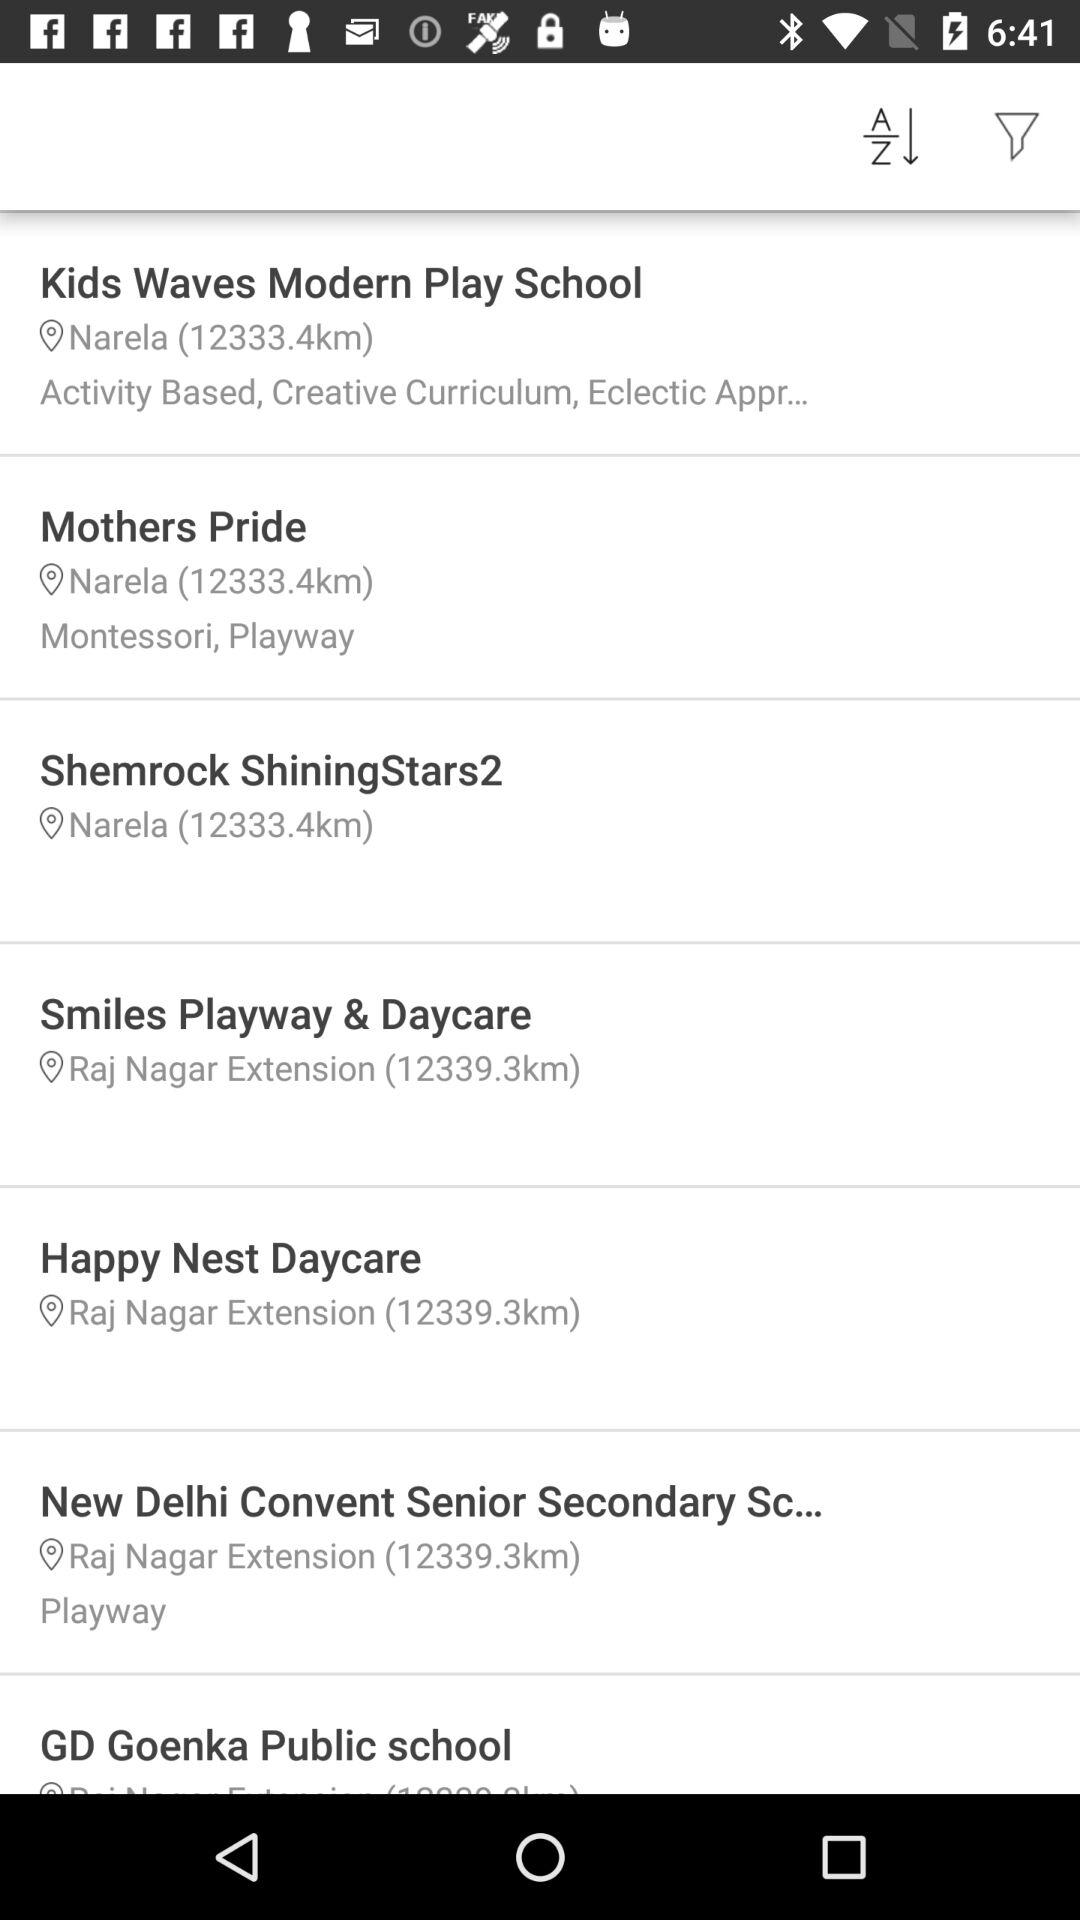What is the current location of the "Kids Waves Modern Play School"? The current location is "Narela". 